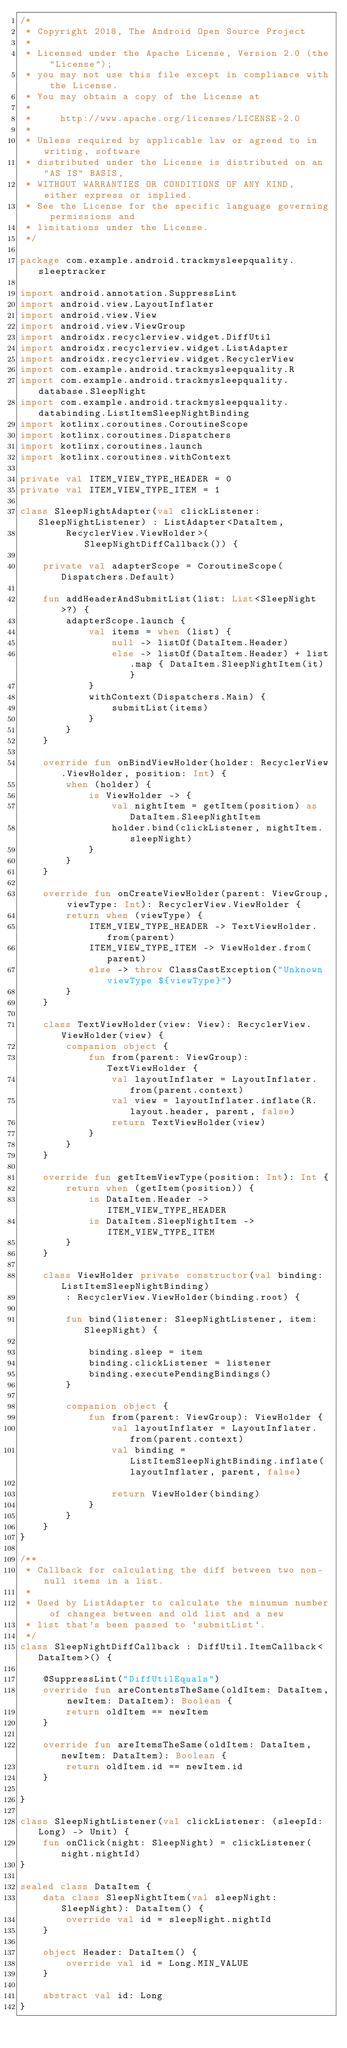<code> <loc_0><loc_0><loc_500><loc_500><_Kotlin_>/*
 * Copyright 2018, The Android Open Source Project
 *
 * Licensed under the Apache License, Version 2.0 (the "License");
 * you may not use this file except in compliance with the License.
 * You may obtain a copy of the License at
 *
 *     http://www.apache.org/licenses/LICENSE-2.0
 *
 * Unless required by applicable law or agreed to in writing, software
 * distributed under the License is distributed on an "AS IS" BASIS,
 * WITHOUT WARRANTIES OR CONDITIONS OF ANY KIND, either express or implied.
 * See the License for the specific language governing permissions and
 * limitations under the License.
 */

package com.example.android.trackmysleepquality.sleeptracker

import android.annotation.SuppressLint
import android.view.LayoutInflater
import android.view.View
import android.view.ViewGroup
import androidx.recyclerview.widget.DiffUtil
import androidx.recyclerview.widget.ListAdapter
import androidx.recyclerview.widget.RecyclerView
import com.example.android.trackmysleepquality.R
import com.example.android.trackmysleepquality.database.SleepNight
import com.example.android.trackmysleepquality.databinding.ListItemSleepNightBinding
import kotlinx.coroutines.CoroutineScope
import kotlinx.coroutines.Dispatchers
import kotlinx.coroutines.launch
import kotlinx.coroutines.withContext

private val ITEM_VIEW_TYPE_HEADER = 0
private val ITEM_VIEW_TYPE_ITEM = 1

class SleepNightAdapter(val clickListener: SleepNightListener) : ListAdapter<DataItem,
        RecyclerView.ViewHolder>(SleepNightDiffCallback()) {

    private val adapterScope = CoroutineScope(Dispatchers.Default)

    fun addHeaderAndSubmitList(list: List<SleepNight>?) {
        adapterScope.launch {
            val items = when (list) {
                null -> listOf(DataItem.Header)
                else -> listOf(DataItem.Header) + list.map { DataItem.SleepNightItem(it) }
            }
            withContext(Dispatchers.Main) {
                submitList(items)
            }
        }
    }

    override fun onBindViewHolder(holder: RecyclerView.ViewHolder, position: Int) {
        when (holder) {
            is ViewHolder -> {
                val nightItem = getItem(position) as DataItem.SleepNightItem
                holder.bind(clickListener, nightItem.sleepNight)
            }
        }
    }

    override fun onCreateViewHolder(parent: ViewGroup, viewType: Int): RecyclerView.ViewHolder {
        return when (viewType) {
            ITEM_VIEW_TYPE_HEADER -> TextViewHolder.from(parent)
            ITEM_VIEW_TYPE_ITEM -> ViewHolder.from(parent)
            else -> throw ClassCastException("Unknown viewType ${viewType}")
        }
    }

    class TextViewHolder(view: View): RecyclerView.ViewHolder(view) {
        companion object {
            fun from(parent: ViewGroup): TextViewHolder {
                val layoutInflater = LayoutInflater.from(parent.context)
                val view = layoutInflater.inflate(R.layout.header, parent, false)
                return TextViewHolder(view)
            }
        }
    }

    override fun getItemViewType(position: Int): Int {
        return when (getItem(position)) {
            is DataItem.Header -> ITEM_VIEW_TYPE_HEADER
            is DataItem.SleepNightItem -> ITEM_VIEW_TYPE_ITEM
        }
    }

    class ViewHolder private constructor(val binding: ListItemSleepNightBinding)
        : RecyclerView.ViewHolder(binding.root) {

        fun bind(listener: SleepNightListener, item: SleepNight) {

            binding.sleep = item
            binding.clickListener = listener
            binding.executePendingBindings()
        }

        companion object {
            fun from(parent: ViewGroup): ViewHolder {
                val layoutInflater = LayoutInflater.from(parent.context)
                val binding = ListItemSleepNightBinding.inflate(layoutInflater, parent, false)

                return ViewHolder(binding)
            }
        }
    }
}

/**
 * Callback for calculating the diff between two non-null items in a list.
 *
 * Used by ListAdapter to calculate the minumum number of changes between and old list and a new
 * list that's been passed to `submitList`.
 */
class SleepNightDiffCallback : DiffUtil.ItemCallback<DataItem>() {

    @SuppressLint("DiffUtilEquals")
    override fun areContentsTheSame(oldItem: DataItem, newItem: DataItem): Boolean {
        return oldItem == newItem
    }

    override fun areItemsTheSame(oldItem: DataItem, newItem: DataItem): Boolean {
        return oldItem.id == newItem.id
    }

}

class SleepNightListener(val clickListener: (sleepId: Long) -> Unit) {
    fun onClick(night: SleepNight) = clickListener(night.nightId)
}

sealed class DataItem {
    data class SleepNightItem(val sleepNight: SleepNight): DataItem() {
        override val id = sleepNight.nightId
    }

    object Header: DataItem() {
        override val id = Long.MIN_VALUE
    }

    abstract val id: Long
}</code> 